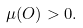Convert formula to latex. <formula><loc_0><loc_0><loc_500><loc_500>\mu ( O ) > 0 .</formula> 